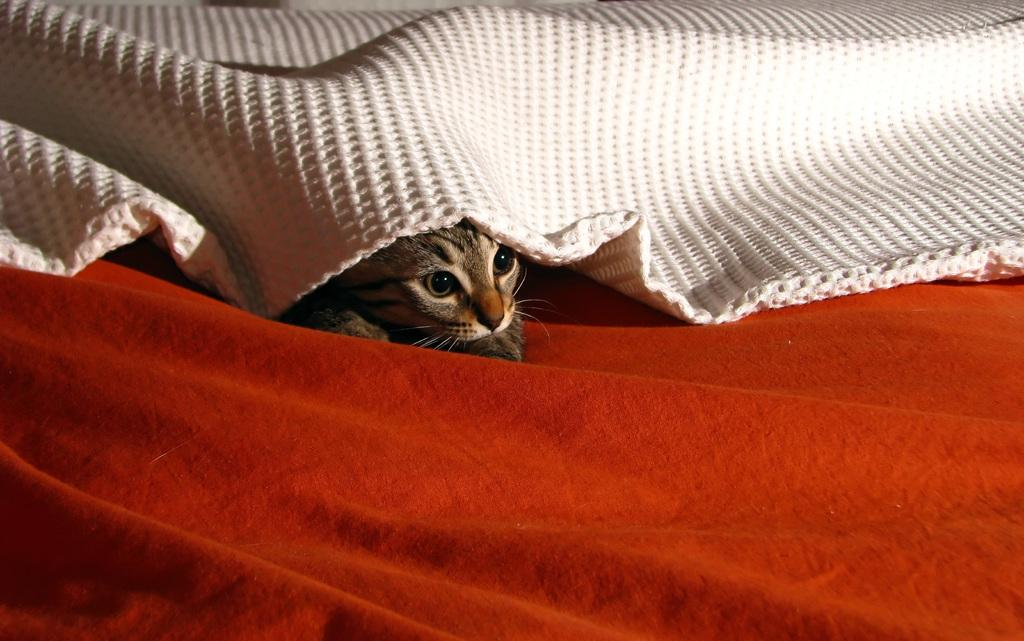What type of animal is in the image? There is a cat in the image. What is the cat sitting on? The cat is on a red cloth. What other textile item is present in the image? There is a white blanket in the image. What colors can be seen on the cat? The cat has brown and black colors. What type of art is the cat creating on the white blanket? There is no indication in the image that the cat is creating any art on the white blanket. 